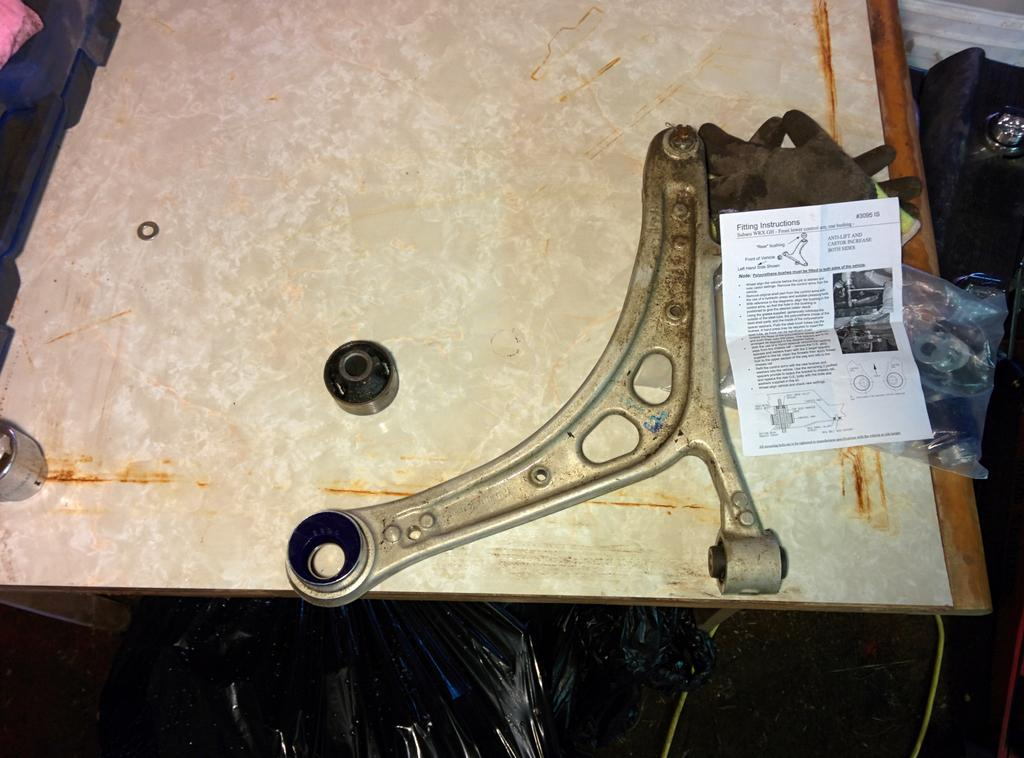What type of furniture is present in the image? There is a wooden table in the image. What is placed on the wooden table? There is a paper and a cover on the wooden table. What type of clothing item is visible in the image? There are gloves in the image. How does the ladybug transport the gloves in the image? There is no ladybug present in the image, so it cannot transport the gloves. 